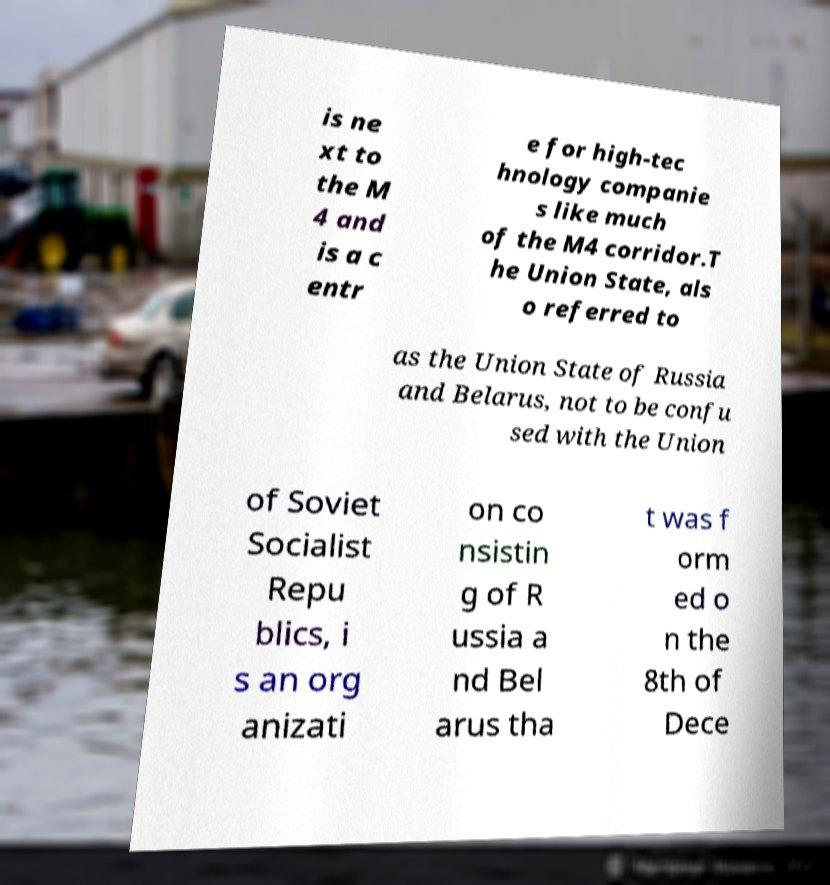Please identify and transcribe the text found in this image. is ne xt to the M 4 and is a c entr e for high-tec hnology companie s like much of the M4 corridor.T he Union State, als o referred to as the Union State of Russia and Belarus, not to be confu sed with the Union of Soviet Socialist Repu blics, i s an org anizati on co nsistin g of R ussia a nd Bel arus tha t was f orm ed o n the 8th of Dece 